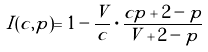<formula> <loc_0><loc_0><loc_500><loc_500>I ( c , p ) = 1 - \frac { V } { c } \cdot \frac { c p + 2 - p } { V + 2 - p }</formula> 